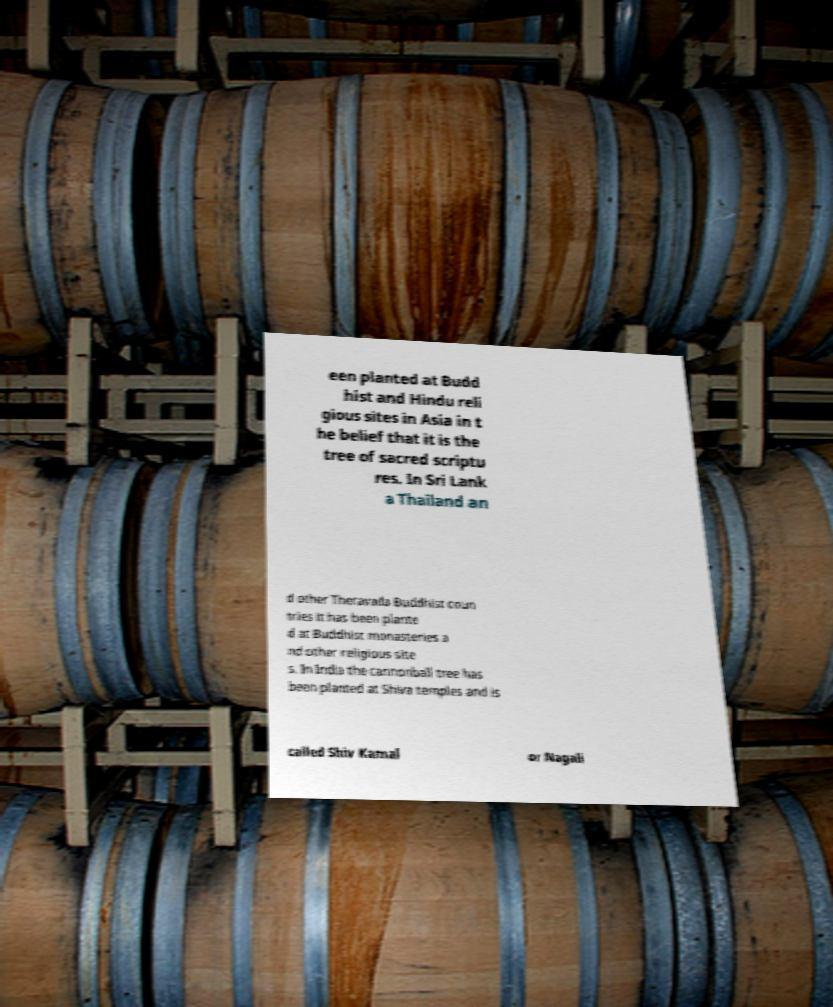For documentation purposes, I need the text within this image transcribed. Could you provide that? een planted at Budd hist and Hindu reli gious sites in Asia in t he belief that it is the tree of sacred scriptu res. In Sri Lank a Thailand an d other Theravada Buddhist coun tries it has been plante d at Buddhist monasteries a nd other religious site s. In India the cannonball tree has been planted at Shiva temples and is called Shiv Kamal or Nagali 